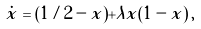<formula> <loc_0><loc_0><loc_500><loc_500>\dot { x } = ( 1 / 2 - x ) + \lambda x ( 1 - x ) \, ,</formula> 